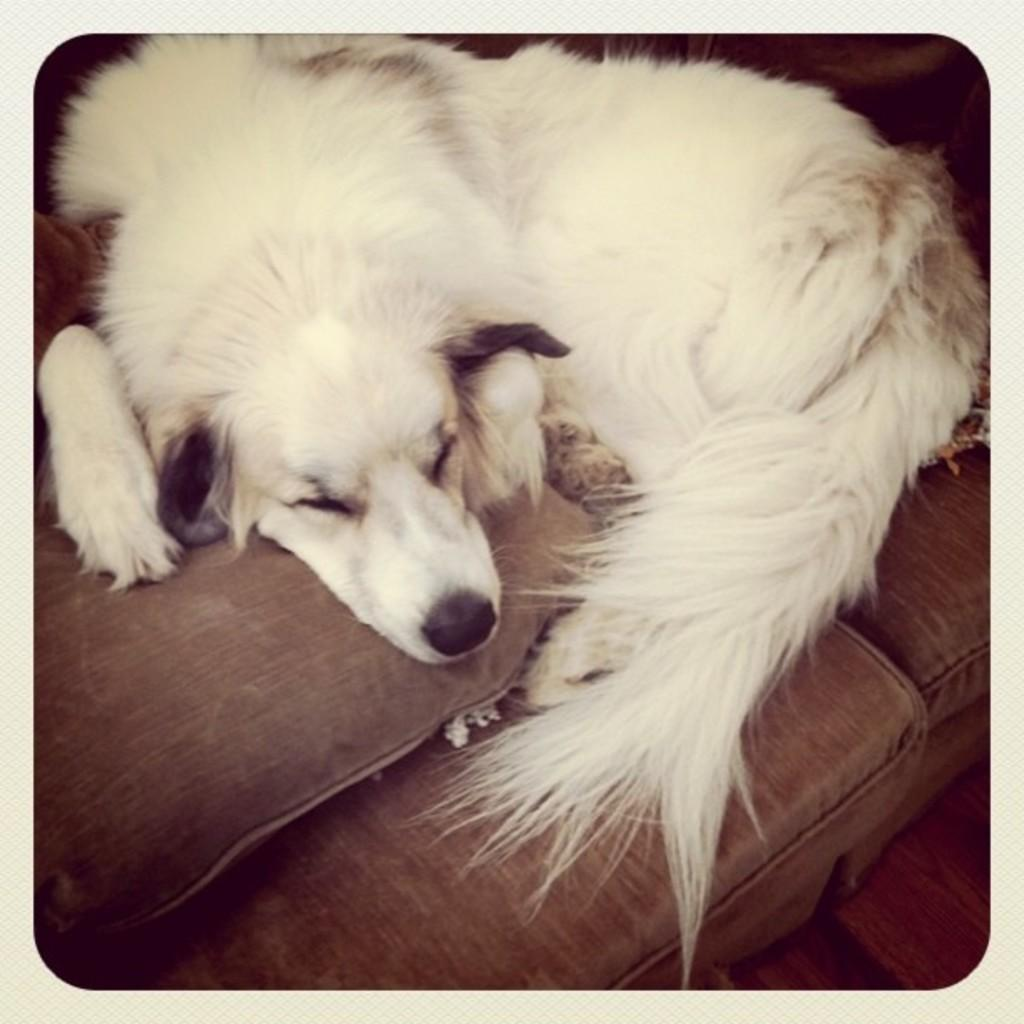What type of animal is present in the image? There is a dog in the image. What is the color of the dog? The dog is white in color. Where is the dog located in the image? The dog is on a couch. What is the color of the couch? The couch is brown in color. What type of bread is the dog eating on the couch? There is no bread or loaf present in the image; the dog is simply sitting on the couch. 